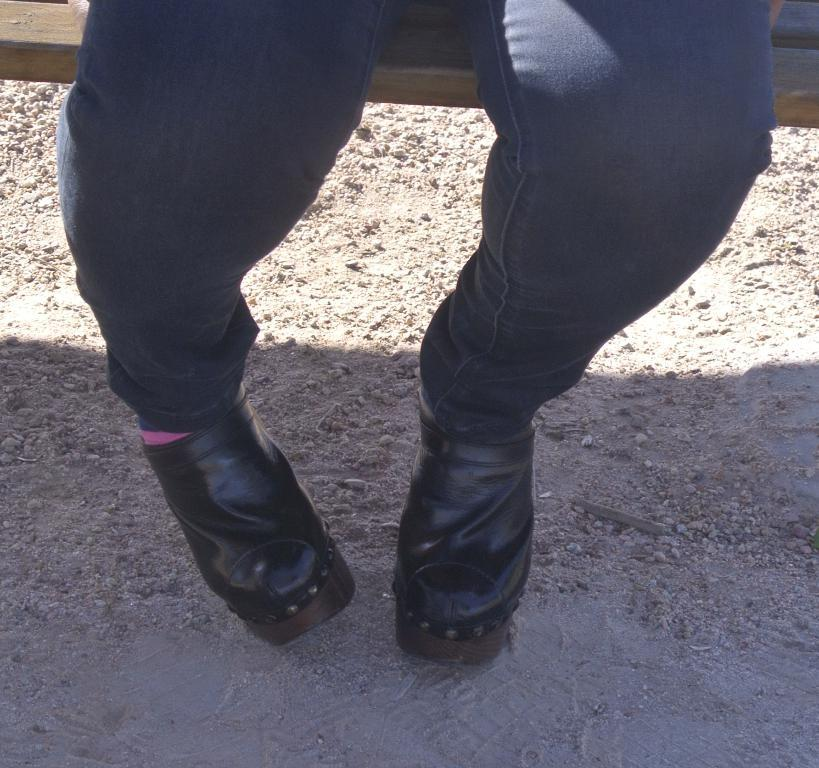What is present in the image? There is a person in the image. What can be observed about the person's attire? The person is wearing shoes. What is the person doing in the image? The person is sitting on a bench. How is the bench positioned in the image? The bench is placed on the ground. How many oranges are being held by the person's chin in the image? There are no oranges or any reference to a chin in the image. Is there a box visible in the image? There is no box present in the image. 